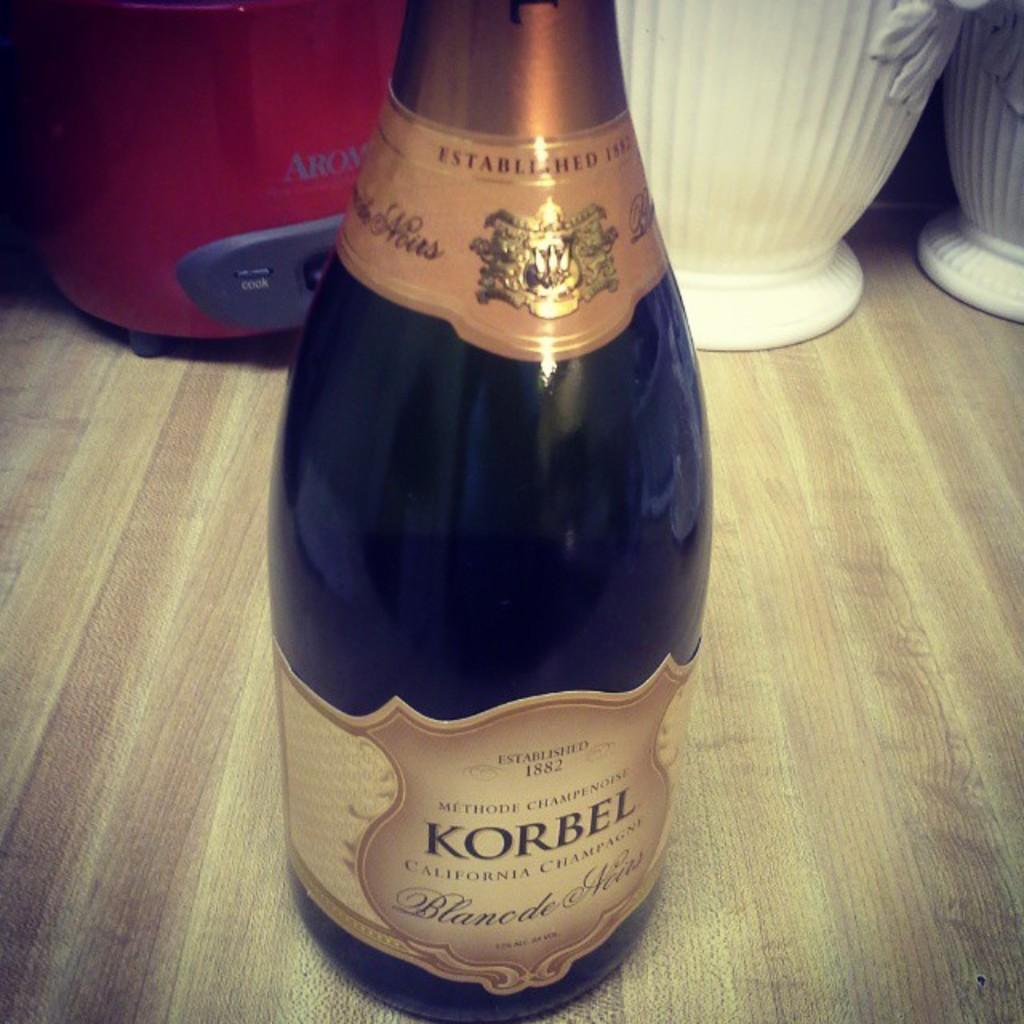<image>
Offer a succinct explanation of the picture presented. A bottle of Korbel California Champagne with gold label. 